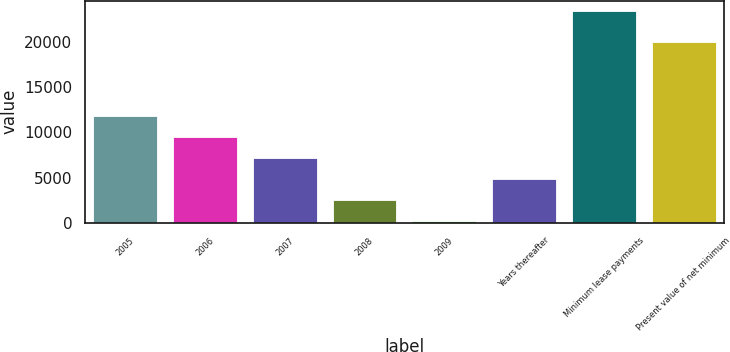Convert chart to OTSL. <chart><loc_0><loc_0><loc_500><loc_500><bar_chart><fcel>2005<fcel>2006<fcel>2007<fcel>2008<fcel>2009<fcel>Years thereafter<fcel>Minimum lease payments<fcel>Present value of net minimum<nl><fcel>11828<fcel>9509.8<fcel>7191.6<fcel>2555.2<fcel>237<fcel>4873.4<fcel>23419<fcel>20031<nl></chart> 